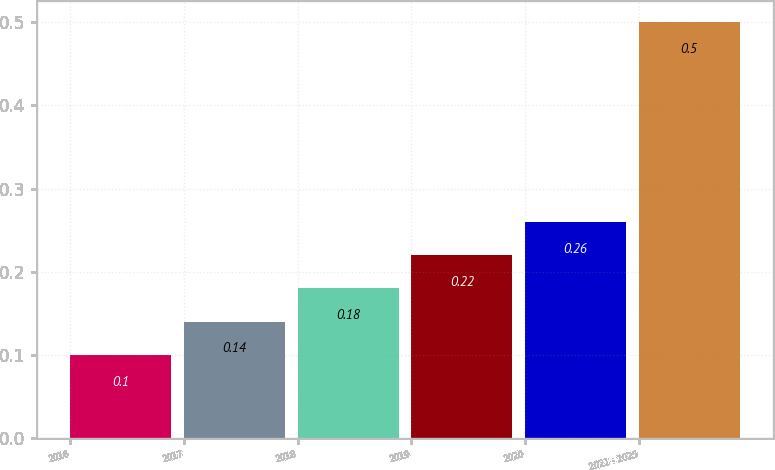Convert chart to OTSL. <chart><loc_0><loc_0><loc_500><loc_500><bar_chart><fcel>2016<fcel>2017<fcel>2018<fcel>2019<fcel>2020<fcel>2021 - 2025<nl><fcel>0.1<fcel>0.14<fcel>0.18<fcel>0.22<fcel>0.26<fcel>0.5<nl></chart> 